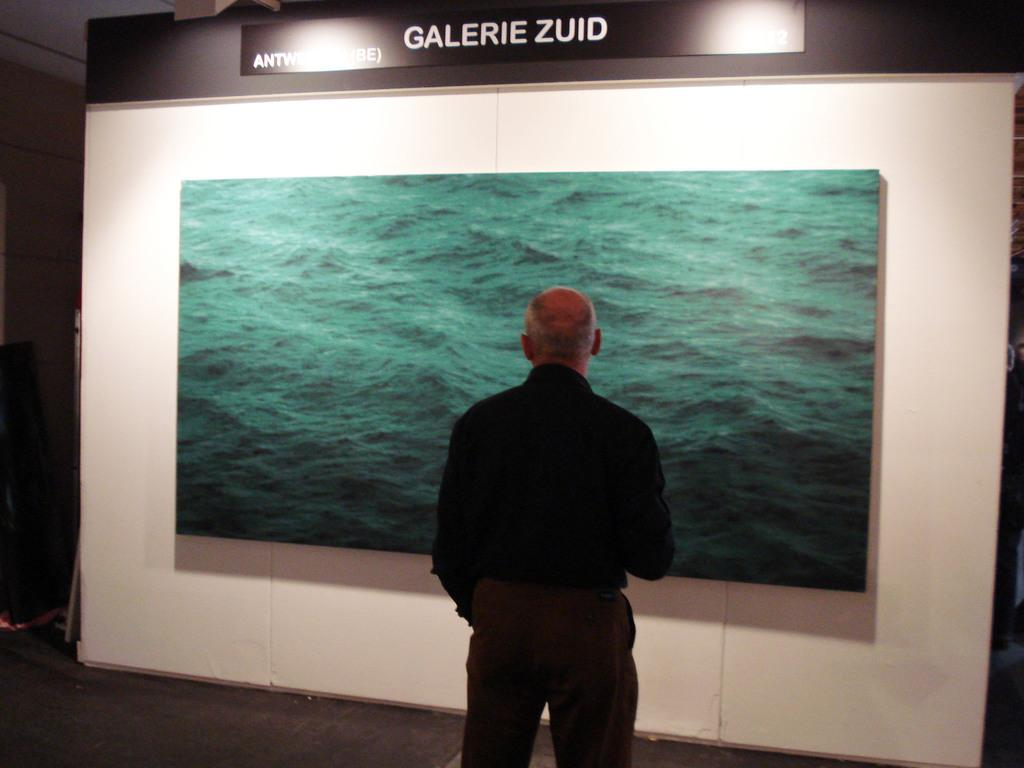What is the main subject of the image? There is a person standing in the image. Where is the person standing? The person is standing on a floor. What can be seen in the background of the image? There is a wall in the background of the image. What is on the wall? There is a screen on the wall. What is visible at the top of the image? There is text visible at the top of the image. What else can be seen in the image? There are lights present in the image. What type of juice is being served in the harbor in the image? There is no harbor or juice present in the image; it features a person standing on a floor with a wall and screen in the background. 